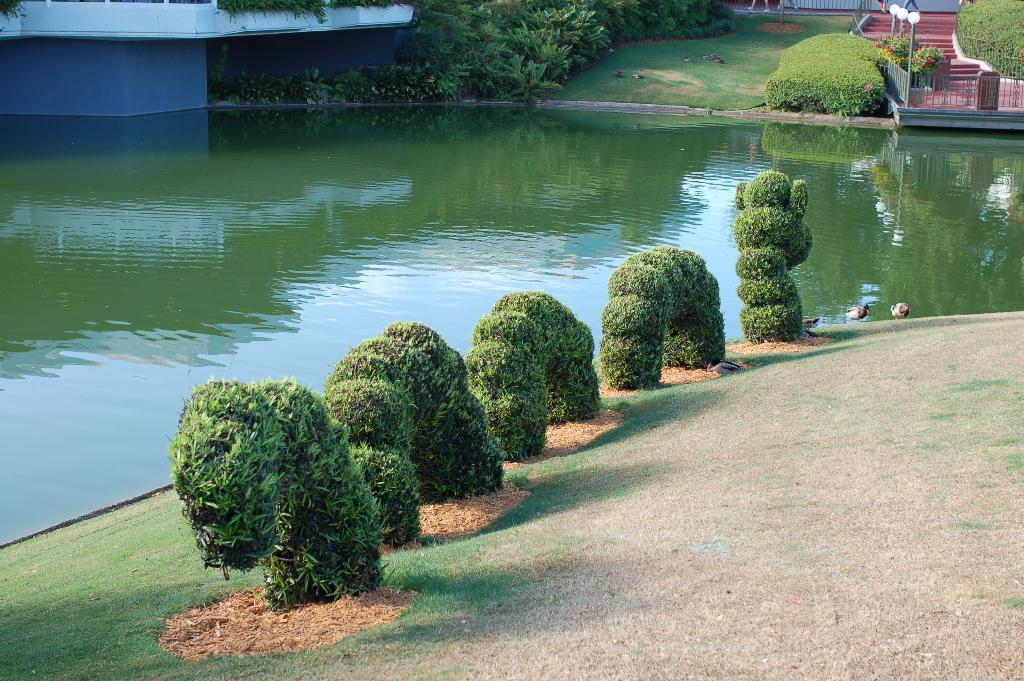What type of vegetation can be seen in the image? There is grass and plants visible in the image. What type of animals can be seen in the image? Birds can be seen in the image. What is the water element in the image? There is water visible in the image. What architectural features are present in the image? There are steps, light poles, fences, and a wall in the image. What other objects can be seen in the image? There are some objects in the image. How does the yam contribute to the force applied to the wall in the image? There is no yam present in the image, and therefore it cannot contribute to any force applied to the wall. 